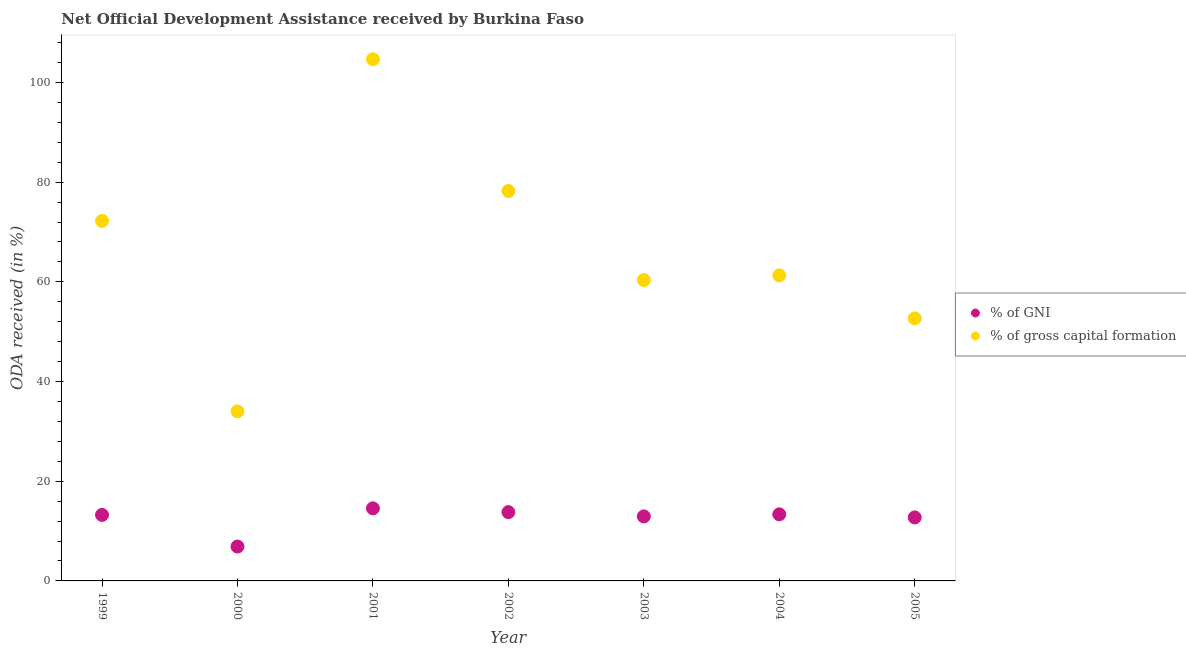How many different coloured dotlines are there?
Your answer should be compact. 2. What is the oda received as percentage of gni in 2005?
Give a very brief answer. 12.74. Across all years, what is the maximum oda received as percentage of gni?
Your answer should be compact. 14.56. Across all years, what is the minimum oda received as percentage of gross capital formation?
Your response must be concise. 34.03. In which year was the oda received as percentage of gross capital formation maximum?
Your answer should be very brief. 2001. What is the total oda received as percentage of gni in the graph?
Your answer should be very brief. 87.55. What is the difference between the oda received as percentage of gni in 2000 and that in 2003?
Keep it short and to the point. -6.04. What is the difference between the oda received as percentage of gross capital formation in 2005 and the oda received as percentage of gni in 2004?
Your response must be concise. 39.31. What is the average oda received as percentage of gross capital formation per year?
Give a very brief answer. 66.21. In the year 2000, what is the difference between the oda received as percentage of gross capital formation and oda received as percentage of gni?
Give a very brief answer. 27.13. What is the ratio of the oda received as percentage of gross capital formation in 2000 to that in 2003?
Provide a short and direct response. 0.56. Is the difference between the oda received as percentage of gni in 2000 and 2003 greater than the difference between the oda received as percentage of gross capital formation in 2000 and 2003?
Your answer should be compact. Yes. What is the difference between the highest and the second highest oda received as percentage of gross capital formation?
Provide a succinct answer. 26.43. What is the difference between the highest and the lowest oda received as percentage of gni?
Make the answer very short. 7.66. Is the sum of the oda received as percentage of gni in 2002 and 2004 greater than the maximum oda received as percentage of gross capital formation across all years?
Make the answer very short. No. Is the oda received as percentage of gross capital formation strictly greater than the oda received as percentage of gni over the years?
Offer a very short reply. Yes. How many dotlines are there?
Make the answer very short. 2. How many years are there in the graph?
Offer a very short reply. 7. Does the graph contain any zero values?
Ensure brevity in your answer.  No. How are the legend labels stacked?
Make the answer very short. Vertical. What is the title of the graph?
Give a very brief answer. Net Official Development Assistance received by Burkina Faso. What is the label or title of the Y-axis?
Provide a succinct answer. ODA received (in %). What is the ODA received (in %) of % of GNI in 1999?
Offer a terse response. 13.25. What is the ODA received (in %) of % of gross capital formation in 1999?
Your answer should be very brief. 72.23. What is the ODA received (in %) in % of GNI in 2000?
Give a very brief answer. 6.9. What is the ODA received (in %) in % of gross capital formation in 2000?
Your answer should be compact. 34.03. What is the ODA received (in %) of % of GNI in 2001?
Ensure brevity in your answer.  14.56. What is the ODA received (in %) in % of gross capital formation in 2001?
Your answer should be compact. 104.66. What is the ODA received (in %) of % of GNI in 2002?
Offer a very short reply. 13.8. What is the ODA received (in %) of % of gross capital formation in 2002?
Provide a short and direct response. 78.23. What is the ODA received (in %) in % of GNI in 2003?
Your response must be concise. 12.94. What is the ODA received (in %) in % of gross capital formation in 2003?
Provide a succinct answer. 60.37. What is the ODA received (in %) of % of GNI in 2004?
Offer a very short reply. 13.36. What is the ODA received (in %) in % of gross capital formation in 2004?
Provide a short and direct response. 61.3. What is the ODA received (in %) in % of GNI in 2005?
Give a very brief answer. 12.74. What is the ODA received (in %) of % of gross capital formation in 2005?
Make the answer very short. 52.68. Across all years, what is the maximum ODA received (in %) in % of GNI?
Your answer should be compact. 14.56. Across all years, what is the maximum ODA received (in %) of % of gross capital formation?
Your answer should be very brief. 104.66. Across all years, what is the minimum ODA received (in %) of % of GNI?
Give a very brief answer. 6.9. Across all years, what is the minimum ODA received (in %) of % of gross capital formation?
Provide a short and direct response. 34.03. What is the total ODA received (in %) of % of GNI in the graph?
Provide a short and direct response. 87.55. What is the total ODA received (in %) in % of gross capital formation in the graph?
Offer a terse response. 463.5. What is the difference between the ODA received (in %) of % of GNI in 1999 and that in 2000?
Ensure brevity in your answer.  6.35. What is the difference between the ODA received (in %) of % of gross capital formation in 1999 and that in 2000?
Make the answer very short. 38.21. What is the difference between the ODA received (in %) in % of GNI in 1999 and that in 2001?
Keep it short and to the point. -1.31. What is the difference between the ODA received (in %) of % of gross capital formation in 1999 and that in 2001?
Keep it short and to the point. -32.43. What is the difference between the ODA received (in %) in % of GNI in 1999 and that in 2002?
Your answer should be compact. -0.55. What is the difference between the ODA received (in %) of % of gross capital formation in 1999 and that in 2002?
Keep it short and to the point. -6. What is the difference between the ODA received (in %) in % of GNI in 1999 and that in 2003?
Your response must be concise. 0.3. What is the difference between the ODA received (in %) in % of gross capital formation in 1999 and that in 2003?
Provide a short and direct response. 11.86. What is the difference between the ODA received (in %) in % of GNI in 1999 and that in 2004?
Keep it short and to the point. -0.12. What is the difference between the ODA received (in %) in % of gross capital formation in 1999 and that in 2004?
Make the answer very short. 10.93. What is the difference between the ODA received (in %) of % of GNI in 1999 and that in 2005?
Provide a succinct answer. 0.5. What is the difference between the ODA received (in %) of % of gross capital formation in 1999 and that in 2005?
Offer a very short reply. 19.56. What is the difference between the ODA received (in %) in % of GNI in 2000 and that in 2001?
Your answer should be very brief. -7.66. What is the difference between the ODA received (in %) in % of gross capital formation in 2000 and that in 2001?
Offer a very short reply. -70.63. What is the difference between the ODA received (in %) in % of GNI in 2000 and that in 2002?
Offer a terse response. -6.9. What is the difference between the ODA received (in %) of % of gross capital formation in 2000 and that in 2002?
Give a very brief answer. -44.2. What is the difference between the ODA received (in %) of % of GNI in 2000 and that in 2003?
Your answer should be compact. -6.04. What is the difference between the ODA received (in %) of % of gross capital formation in 2000 and that in 2003?
Provide a short and direct response. -26.34. What is the difference between the ODA received (in %) in % of GNI in 2000 and that in 2004?
Your answer should be compact. -6.47. What is the difference between the ODA received (in %) in % of gross capital formation in 2000 and that in 2004?
Your answer should be very brief. -27.27. What is the difference between the ODA received (in %) in % of GNI in 2000 and that in 2005?
Offer a terse response. -5.84. What is the difference between the ODA received (in %) in % of gross capital formation in 2000 and that in 2005?
Your answer should be very brief. -18.65. What is the difference between the ODA received (in %) in % of GNI in 2001 and that in 2002?
Keep it short and to the point. 0.76. What is the difference between the ODA received (in %) in % of gross capital formation in 2001 and that in 2002?
Give a very brief answer. 26.43. What is the difference between the ODA received (in %) in % of GNI in 2001 and that in 2003?
Your response must be concise. 1.62. What is the difference between the ODA received (in %) of % of gross capital formation in 2001 and that in 2003?
Your answer should be compact. 44.29. What is the difference between the ODA received (in %) in % of GNI in 2001 and that in 2004?
Your response must be concise. 1.19. What is the difference between the ODA received (in %) of % of gross capital formation in 2001 and that in 2004?
Make the answer very short. 43.36. What is the difference between the ODA received (in %) in % of GNI in 2001 and that in 2005?
Provide a succinct answer. 1.82. What is the difference between the ODA received (in %) in % of gross capital formation in 2001 and that in 2005?
Give a very brief answer. 51.99. What is the difference between the ODA received (in %) in % of GNI in 2002 and that in 2003?
Ensure brevity in your answer.  0.86. What is the difference between the ODA received (in %) of % of gross capital formation in 2002 and that in 2003?
Your answer should be compact. 17.86. What is the difference between the ODA received (in %) in % of GNI in 2002 and that in 2004?
Provide a short and direct response. 0.43. What is the difference between the ODA received (in %) of % of gross capital formation in 2002 and that in 2004?
Your answer should be very brief. 16.93. What is the difference between the ODA received (in %) of % of GNI in 2002 and that in 2005?
Give a very brief answer. 1.06. What is the difference between the ODA received (in %) in % of gross capital formation in 2002 and that in 2005?
Make the answer very short. 25.55. What is the difference between the ODA received (in %) in % of GNI in 2003 and that in 2004?
Your answer should be compact. -0.42. What is the difference between the ODA received (in %) of % of gross capital formation in 2003 and that in 2004?
Give a very brief answer. -0.93. What is the difference between the ODA received (in %) in % of GNI in 2003 and that in 2005?
Offer a terse response. 0.2. What is the difference between the ODA received (in %) of % of gross capital formation in 2003 and that in 2005?
Provide a succinct answer. 7.69. What is the difference between the ODA received (in %) of % of GNI in 2004 and that in 2005?
Your answer should be compact. 0.62. What is the difference between the ODA received (in %) in % of gross capital formation in 2004 and that in 2005?
Provide a succinct answer. 8.63. What is the difference between the ODA received (in %) of % of GNI in 1999 and the ODA received (in %) of % of gross capital formation in 2000?
Provide a short and direct response. -20.78. What is the difference between the ODA received (in %) in % of GNI in 1999 and the ODA received (in %) in % of gross capital formation in 2001?
Keep it short and to the point. -91.42. What is the difference between the ODA received (in %) in % of GNI in 1999 and the ODA received (in %) in % of gross capital formation in 2002?
Keep it short and to the point. -64.99. What is the difference between the ODA received (in %) in % of GNI in 1999 and the ODA received (in %) in % of gross capital formation in 2003?
Your answer should be very brief. -47.12. What is the difference between the ODA received (in %) in % of GNI in 1999 and the ODA received (in %) in % of gross capital formation in 2004?
Keep it short and to the point. -48.06. What is the difference between the ODA received (in %) in % of GNI in 1999 and the ODA received (in %) in % of gross capital formation in 2005?
Ensure brevity in your answer.  -39.43. What is the difference between the ODA received (in %) of % of GNI in 2000 and the ODA received (in %) of % of gross capital formation in 2001?
Provide a succinct answer. -97.76. What is the difference between the ODA received (in %) of % of GNI in 2000 and the ODA received (in %) of % of gross capital formation in 2002?
Make the answer very short. -71.33. What is the difference between the ODA received (in %) in % of GNI in 2000 and the ODA received (in %) in % of gross capital formation in 2003?
Your answer should be compact. -53.47. What is the difference between the ODA received (in %) in % of GNI in 2000 and the ODA received (in %) in % of gross capital formation in 2004?
Keep it short and to the point. -54.4. What is the difference between the ODA received (in %) in % of GNI in 2000 and the ODA received (in %) in % of gross capital formation in 2005?
Your response must be concise. -45.78. What is the difference between the ODA received (in %) in % of GNI in 2001 and the ODA received (in %) in % of gross capital formation in 2002?
Keep it short and to the point. -63.67. What is the difference between the ODA received (in %) in % of GNI in 2001 and the ODA received (in %) in % of gross capital formation in 2003?
Keep it short and to the point. -45.81. What is the difference between the ODA received (in %) of % of GNI in 2001 and the ODA received (in %) of % of gross capital formation in 2004?
Your answer should be compact. -46.74. What is the difference between the ODA received (in %) of % of GNI in 2001 and the ODA received (in %) of % of gross capital formation in 2005?
Keep it short and to the point. -38.12. What is the difference between the ODA received (in %) of % of GNI in 2002 and the ODA received (in %) of % of gross capital formation in 2003?
Offer a terse response. -46.57. What is the difference between the ODA received (in %) in % of GNI in 2002 and the ODA received (in %) in % of gross capital formation in 2004?
Provide a short and direct response. -47.5. What is the difference between the ODA received (in %) in % of GNI in 2002 and the ODA received (in %) in % of gross capital formation in 2005?
Offer a very short reply. -38.88. What is the difference between the ODA received (in %) of % of GNI in 2003 and the ODA received (in %) of % of gross capital formation in 2004?
Ensure brevity in your answer.  -48.36. What is the difference between the ODA received (in %) of % of GNI in 2003 and the ODA received (in %) of % of gross capital formation in 2005?
Your answer should be compact. -39.74. What is the difference between the ODA received (in %) in % of GNI in 2004 and the ODA received (in %) in % of gross capital formation in 2005?
Your answer should be compact. -39.31. What is the average ODA received (in %) in % of GNI per year?
Your response must be concise. 12.51. What is the average ODA received (in %) of % of gross capital formation per year?
Your answer should be compact. 66.21. In the year 1999, what is the difference between the ODA received (in %) in % of GNI and ODA received (in %) in % of gross capital formation?
Provide a succinct answer. -58.99. In the year 2000, what is the difference between the ODA received (in %) of % of GNI and ODA received (in %) of % of gross capital formation?
Your response must be concise. -27.13. In the year 2001, what is the difference between the ODA received (in %) in % of GNI and ODA received (in %) in % of gross capital formation?
Your answer should be very brief. -90.1. In the year 2002, what is the difference between the ODA received (in %) of % of GNI and ODA received (in %) of % of gross capital formation?
Ensure brevity in your answer.  -64.43. In the year 2003, what is the difference between the ODA received (in %) of % of GNI and ODA received (in %) of % of gross capital formation?
Your answer should be very brief. -47.43. In the year 2004, what is the difference between the ODA received (in %) in % of GNI and ODA received (in %) in % of gross capital formation?
Your answer should be compact. -47.94. In the year 2005, what is the difference between the ODA received (in %) of % of GNI and ODA received (in %) of % of gross capital formation?
Your response must be concise. -39.94. What is the ratio of the ODA received (in %) of % of GNI in 1999 to that in 2000?
Give a very brief answer. 1.92. What is the ratio of the ODA received (in %) in % of gross capital formation in 1999 to that in 2000?
Your answer should be compact. 2.12. What is the ratio of the ODA received (in %) of % of GNI in 1999 to that in 2001?
Your answer should be compact. 0.91. What is the ratio of the ODA received (in %) of % of gross capital formation in 1999 to that in 2001?
Offer a very short reply. 0.69. What is the ratio of the ODA received (in %) in % of GNI in 1999 to that in 2002?
Your answer should be compact. 0.96. What is the ratio of the ODA received (in %) in % of gross capital formation in 1999 to that in 2002?
Offer a terse response. 0.92. What is the ratio of the ODA received (in %) in % of GNI in 1999 to that in 2003?
Provide a succinct answer. 1.02. What is the ratio of the ODA received (in %) in % of gross capital formation in 1999 to that in 2003?
Provide a succinct answer. 1.2. What is the ratio of the ODA received (in %) in % of GNI in 1999 to that in 2004?
Ensure brevity in your answer.  0.99. What is the ratio of the ODA received (in %) in % of gross capital formation in 1999 to that in 2004?
Ensure brevity in your answer.  1.18. What is the ratio of the ODA received (in %) of % of GNI in 1999 to that in 2005?
Provide a short and direct response. 1.04. What is the ratio of the ODA received (in %) in % of gross capital formation in 1999 to that in 2005?
Ensure brevity in your answer.  1.37. What is the ratio of the ODA received (in %) in % of GNI in 2000 to that in 2001?
Make the answer very short. 0.47. What is the ratio of the ODA received (in %) of % of gross capital formation in 2000 to that in 2001?
Offer a terse response. 0.33. What is the ratio of the ODA received (in %) in % of GNI in 2000 to that in 2002?
Your answer should be very brief. 0.5. What is the ratio of the ODA received (in %) in % of gross capital formation in 2000 to that in 2002?
Offer a terse response. 0.43. What is the ratio of the ODA received (in %) in % of GNI in 2000 to that in 2003?
Provide a succinct answer. 0.53. What is the ratio of the ODA received (in %) in % of gross capital formation in 2000 to that in 2003?
Give a very brief answer. 0.56. What is the ratio of the ODA received (in %) in % of GNI in 2000 to that in 2004?
Your answer should be very brief. 0.52. What is the ratio of the ODA received (in %) in % of gross capital formation in 2000 to that in 2004?
Provide a short and direct response. 0.56. What is the ratio of the ODA received (in %) of % of GNI in 2000 to that in 2005?
Keep it short and to the point. 0.54. What is the ratio of the ODA received (in %) in % of gross capital formation in 2000 to that in 2005?
Keep it short and to the point. 0.65. What is the ratio of the ODA received (in %) in % of GNI in 2001 to that in 2002?
Offer a terse response. 1.05. What is the ratio of the ODA received (in %) in % of gross capital formation in 2001 to that in 2002?
Make the answer very short. 1.34. What is the ratio of the ODA received (in %) of % of GNI in 2001 to that in 2003?
Make the answer very short. 1.12. What is the ratio of the ODA received (in %) of % of gross capital formation in 2001 to that in 2003?
Ensure brevity in your answer.  1.73. What is the ratio of the ODA received (in %) in % of GNI in 2001 to that in 2004?
Provide a short and direct response. 1.09. What is the ratio of the ODA received (in %) in % of gross capital formation in 2001 to that in 2004?
Offer a terse response. 1.71. What is the ratio of the ODA received (in %) in % of GNI in 2001 to that in 2005?
Provide a succinct answer. 1.14. What is the ratio of the ODA received (in %) in % of gross capital formation in 2001 to that in 2005?
Provide a succinct answer. 1.99. What is the ratio of the ODA received (in %) of % of GNI in 2002 to that in 2003?
Keep it short and to the point. 1.07. What is the ratio of the ODA received (in %) of % of gross capital formation in 2002 to that in 2003?
Keep it short and to the point. 1.3. What is the ratio of the ODA received (in %) in % of GNI in 2002 to that in 2004?
Give a very brief answer. 1.03. What is the ratio of the ODA received (in %) of % of gross capital formation in 2002 to that in 2004?
Provide a succinct answer. 1.28. What is the ratio of the ODA received (in %) in % of GNI in 2002 to that in 2005?
Make the answer very short. 1.08. What is the ratio of the ODA received (in %) of % of gross capital formation in 2002 to that in 2005?
Offer a terse response. 1.49. What is the ratio of the ODA received (in %) in % of GNI in 2003 to that in 2004?
Keep it short and to the point. 0.97. What is the ratio of the ODA received (in %) of % of GNI in 2003 to that in 2005?
Provide a short and direct response. 1.02. What is the ratio of the ODA received (in %) of % of gross capital formation in 2003 to that in 2005?
Offer a very short reply. 1.15. What is the ratio of the ODA received (in %) of % of GNI in 2004 to that in 2005?
Your answer should be very brief. 1.05. What is the ratio of the ODA received (in %) in % of gross capital formation in 2004 to that in 2005?
Offer a terse response. 1.16. What is the difference between the highest and the second highest ODA received (in %) in % of GNI?
Give a very brief answer. 0.76. What is the difference between the highest and the second highest ODA received (in %) of % of gross capital formation?
Give a very brief answer. 26.43. What is the difference between the highest and the lowest ODA received (in %) in % of GNI?
Provide a short and direct response. 7.66. What is the difference between the highest and the lowest ODA received (in %) in % of gross capital formation?
Provide a short and direct response. 70.63. 